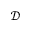Convert formula to latex. <formula><loc_0><loc_0><loc_500><loc_500>\mathcal { D }</formula> 